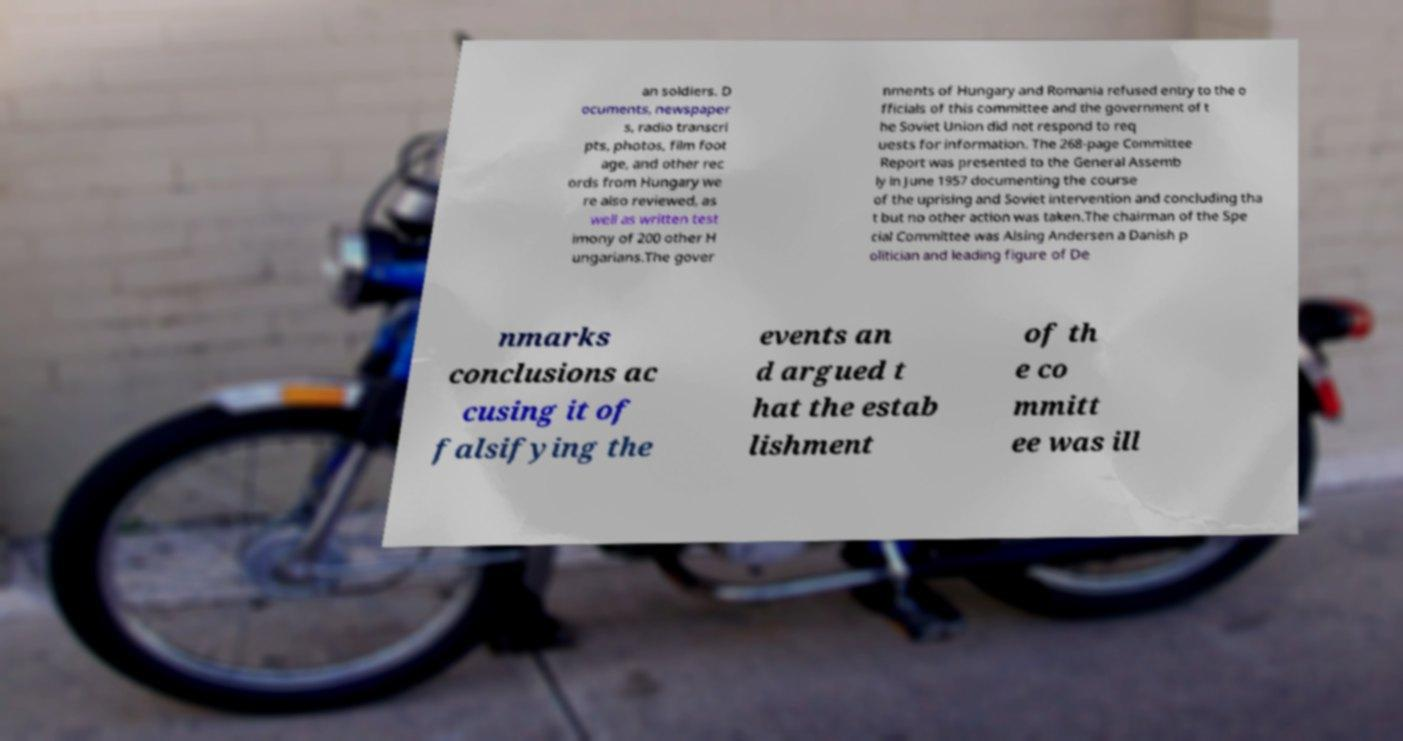For documentation purposes, I need the text within this image transcribed. Could you provide that? an soldiers. D ocuments, newspaper s, radio transcri pts, photos, film foot age, and other rec ords from Hungary we re also reviewed, as well as written test imony of 200 other H ungarians.The gover nments of Hungary and Romania refused entry to the o fficials of this committee and the government of t he Soviet Union did not respond to req uests for information. The 268-page Committee Report was presented to the General Assemb ly in June 1957 documenting the course of the uprising and Soviet intervention and concluding tha t but no other action was taken.The chairman of the Spe cial Committee was Alsing Andersen a Danish p olitician and leading figure of De nmarks conclusions ac cusing it of falsifying the events an d argued t hat the estab lishment of th e co mmitt ee was ill 